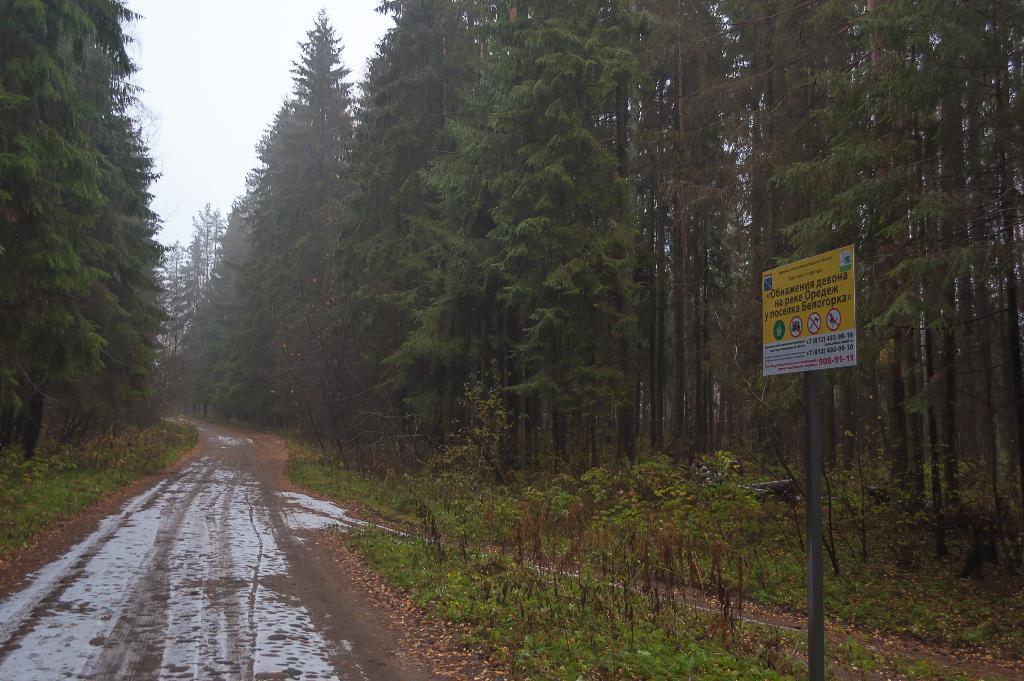Could you give a brief overview of what you see in this image? In the image there is a path in the middle with trees on either side of it and there is a caution board on the right side. 